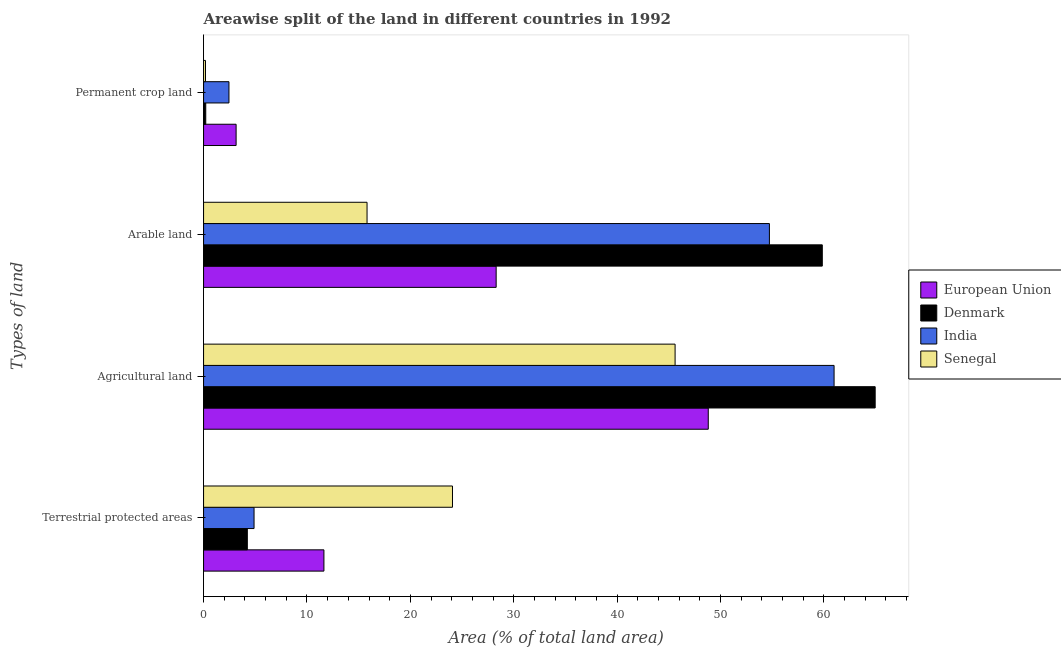What is the label of the 2nd group of bars from the top?
Make the answer very short. Arable land. What is the percentage of land under terrestrial protection in European Union?
Ensure brevity in your answer.  11.64. Across all countries, what is the maximum percentage of area under arable land?
Offer a very short reply. 59.84. Across all countries, what is the minimum percentage of area under permanent crop land?
Provide a succinct answer. 0.19. In which country was the percentage of land under terrestrial protection maximum?
Your response must be concise. Senegal. What is the total percentage of area under agricultural land in the graph?
Ensure brevity in your answer.  220.35. What is the difference between the percentage of area under agricultural land in Denmark and that in Senegal?
Your answer should be compact. 19.35. What is the difference between the percentage of area under permanent crop land in Senegal and the percentage of area under arable land in India?
Your answer should be very brief. -54.54. What is the average percentage of area under agricultural land per country?
Provide a succinct answer. 55.09. What is the difference between the percentage of area under permanent crop land and percentage of area under arable land in India?
Keep it short and to the point. -52.27. In how many countries, is the percentage of area under permanent crop land greater than 18 %?
Give a very brief answer. 0. What is the ratio of the percentage of area under arable land in Senegal to that in India?
Offer a terse response. 0.29. Is the percentage of land under terrestrial protection in Senegal less than that in Denmark?
Your response must be concise. No. What is the difference between the highest and the second highest percentage of land under terrestrial protection?
Ensure brevity in your answer.  12.43. What is the difference between the highest and the lowest percentage of area under permanent crop land?
Offer a terse response. 2.96. Is the sum of the percentage of area under agricultural land in Senegal and India greater than the maximum percentage of land under terrestrial protection across all countries?
Offer a very short reply. Yes. Is it the case that in every country, the sum of the percentage of land under terrestrial protection and percentage of area under permanent crop land is greater than the sum of percentage of area under arable land and percentage of area under agricultural land?
Ensure brevity in your answer.  Yes. What does the 3rd bar from the top in Agricultural land represents?
Your answer should be very brief. Denmark. What does the 1st bar from the bottom in Agricultural land represents?
Offer a terse response. European Union. How many bars are there?
Your answer should be very brief. 16. Are all the bars in the graph horizontal?
Your answer should be very brief. Yes. How many countries are there in the graph?
Your response must be concise. 4. Are the values on the major ticks of X-axis written in scientific E-notation?
Keep it short and to the point. No. Where does the legend appear in the graph?
Offer a terse response. Center right. How many legend labels are there?
Your answer should be very brief. 4. What is the title of the graph?
Your answer should be compact. Areawise split of the land in different countries in 1992. What is the label or title of the X-axis?
Make the answer very short. Area (% of total land area). What is the label or title of the Y-axis?
Ensure brevity in your answer.  Types of land. What is the Area (% of total land area) in European Union in Terrestrial protected areas?
Offer a terse response. 11.64. What is the Area (% of total land area) in Denmark in Terrestrial protected areas?
Your answer should be very brief. 4.23. What is the Area (% of total land area) in India in Terrestrial protected areas?
Offer a very short reply. 4.88. What is the Area (% of total land area) of Senegal in Terrestrial protected areas?
Your answer should be compact. 24.07. What is the Area (% of total land area) in European Union in Agricultural land?
Keep it short and to the point. 48.81. What is the Area (% of total land area) in Denmark in Agricultural land?
Keep it short and to the point. 64.95. What is the Area (% of total land area) in India in Agricultural land?
Provide a succinct answer. 60.98. What is the Area (% of total land area) of Senegal in Agricultural land?
Make the answer very short. 45.6. What is the Area (% of total land area) of European Union in Arable land?
Give a very brief answer. 28.3. What is the Area (% of total land area) of Denmark in Arable land?
Ensure brevity in your answer.  59.84. What is the Area (% of total land area) in India in Arable land?
Your response must be concise. 54.72. What is the Area (% of total land area) of Senegal in Arable land?
Your answer should be very brief. 15.81. What is the Area (% of total land area) of European Union in Permanent crop land?
Provide a short and direct response. 3.15. What is the Area (% of total land area) in Denmark in Permanent crop land?
Offer a terse response. 0.21. What is the Area (% of total land area) of India in Permanent crop land?
Keep it short and to the point. 2.46. What is the Area (% of total land area) in Senegal in Permanent crop land?
Provide a succinct answer. 0.19. Across all Types of land, what is the maximum Area (% of total land area) in European Union?
Keep it short and to the point. 48.81. Across all Types of land, what is the maximum Area (% of total land area) of Denmark?
Provide a succinct answer. 64.95. Across all Types of land, what is the maximum Area (% of total land area) of India?
Provide a succinct answer. 60.98. Across all Types of land, what is the maximum Area (% of total land area) of Senegal?
Your answer should be very brief. 45.6. Across all Types of land, what is the minimum Area (% of total land area) of European Union?
Your response must be concise. 3.15. Across all Types of land, what is the minimum Area (% of total land area) of Denmark?
Make the answer very short. 0.21. Across all Types of land, what is the minimum Area (% of total land area) of India?
Make the answer very short. 2.46. Across all Types of land, what is the minimum Area (% of total land area) in Senegal?
Your answer should be very brief. 0.19. What is the total Area (% of total land area) of European Union in the graph?
Offer a terse response. 91.9. What is the total Area (% of total land area) of Denmark in the graph?
Ensure brevity in your answer.  129.24. What is the total Area (% of total land area) in India in the graph?
Your answer should be compact. 123.04. What is the total Area (% of total land area) of Senegal in the graph?
Offer a very short reply. 85.67. What is the difference between the Area (% of total land area) in European Union in Terrestrial protected areas and that in Agricultural land?
Ensure brevity in your answer.  -37.17. What is the difference between the Area (% of total land area) in Denmark in Terrestrial protected areas and that in Agricultural land?
Your response must be concise. -60.72. What is the difference between the Area (% of total land area) in India in Terrestrial protected areas and that in Agricultural land?
Keep it short and to the point. -56.1. What is the difference between the Area (% of total land area) of Senegal in Terrestrial protected areas and that in Agricultural land?
Offer a very short reply. -21.53. What is the difference between the Area (% of total land area) of European Union in Terrestrial protected areas and that in Arable land?
Provide a succinct answer. -16.66. What is the difference between the Area (% of total land area) of Denmark in Terrestrial protected areas and that in Arable land?
Your answer should be compact. -55.61. What is the difference between the Area (% of total land area) in India in Terrestrial protected areas and that in Arable land?
Ensure brevity in your answer.  -49.84. What is the difference between the Area (% of total land area) in Senegal in Terrestrial protected areas and that in Arable land?
Give a very brief answer. 8.26. What is the difference between the Area (% of total land area) of European Union in Terrestrial protected areas and that in Permanent crop land?
Give a very brief answer. 8.49. What is the difference between the Area (% of total land area) of Denmark in Terrestrial protected areas and that in Permanent crop land?
Ensure brevity in your answer.  4.02. What is the difference between the Area (% of total land area) of India in Terrestrial protected areas and that in Permanent crop land?
Offer a very short reply. 2.43. What is the difference between the Area (% of total land area) of Senegal in Terrestrial protected areas and that in Permanent crop land?
Provide a short and direct response. 23.89. What is the difference between the Area (% of total land area) of European Union in Agricultural land and that in Arable land?
Provide a succinct answer. 20.51. What is the difference between the Area (% of total land area) of Denmark in Agricultural land and that in Arable land?
Your answer should be compact. 5.11. What is the difference between the Area (% of total land area) of India in Agricultural land and that in Arable land?
Provide a short and direct response. 6.26. What is the difference between the Area (% of total land area) of Senegal in Agricultural land and that in Arable land?
Ensure brevity in your answer.  29.79. What is the difference between the Area (% of total land area) of European Union in Agricultural land and that in Permanent crop land?
Offer a terse response. 45.66. What is the difference between the Area (% of total land area) of Denmark in Agricultural land and that in Permanent crop land?
Ensure brevity in your answer.  64.74. What is the difference between the Area (% of total land area) of India in Agricultural land and that in Permanent crop land?
Offer a very short reply. 58.52. What is the difference between the Area (% of total land area) in Senegal in Agricultural land and that in Permanent crop land?
Your answer should be compact. 45.42. What is the difference between the Area (% of total land area) of European Union in Arable land and that in Permanent crop land?
Keep it short and to the point. 25.15. What is the difference between the Area (% of total land area) in Denmark in Arable land and that in Permanent crop land?
Your answer should be compact. 59.63. What is the difference between the Area (% of total land area) in India in Arable land and that in Permanent crop land?
Ensure brevity in your answer.  52.27. What is the difference between the Area (% of total land area) in Senegal in Arable land and that in Permanent crop land?
Offer a terse response. 15.62. What is the difference between the Area (% of total land area) of European Union in Terrestrial protected areas and the Area (% of total land area) of Denmark in Agricultural land?
Your answer should be very brief. -53.31. What is the difference between the Area (% of total land area) of European Union in Terrestrial protected areas and the Area (% of total land area) of India in Agricultural land?
Your answer should be compact. -49.34. What is the difference between the Area (% of total land area) of European Union in Terrestrial protected areas and the Area (% of total land area) of Senegal in Agricultural land?
Keep it short and to the point. -33.96. What is the difference between the Area (% of total land area) in Denmark in Terrestrial protected areas and the Area (% of total land area) in India in Agricultural land?
Offer a terse response. -56.75. What is the difference between the Area (% of total land area) of Denmark in Terrestrial protected areas and the Area (% of total land area) of Senegal in Agricultural land?
Keep it short and to the point. -41.37. What is the difference between the Area (% of total land area) in India in Terrestrial protected areas and the Area (% of total land area) in Senegal in Agricultural land?
Provide a short and direct response. -40.72. What is the difference between the Area (% of total land area) of European Union in Terrestrial protected areas and the Area (% of total land area) of Denmark in Arable land?
Make the answer very short. -48.2. What is the difference between the Area (% of total land area) of European Union in Terrestrial protected areas and the Area (% of total land area) of India in Arable land?
Provide a succinct answer. -43.08. What is the difference between the Area (% of total land area) of European Union in Terrestrial protected areas and the Area (% of total land area) of Senegal in Arable land?
Keep it short and to the point. -4.17. What is the difference between the Area (% of total land area) of Denmark in Terrestrial protected areas and the Area (% of total land area) of India in Arable land?
Make the answer very short. -50.49. What is the difference between the Area (% of total land area) in Denmark in Terrestrial protected areas and the Area (% of total land area) in Senegal in Arable land?
Your answer should be compact. -11.58. What is the difference between the Area (% of total land area) in India in Terrestrial protected areas and the Area (% of total land area) in Senegal in Arable land?
Your answer should be very brief. -10.93. What is the difference between the Area (% of total land area) of European Union in Terrestrial protected areas and the Area (% of total land area) of Denmark in Permanent crop land?
Your answer should be very brief. 11.43. What is the difference between the Area (% of total land area) in European Union in Terrestrial protected areas and the Area (% of total land area) in India in Permanent crop land?
Offer a terse response. 9.18. What is the difference between the Area (% of total land area) in European Union in Terrestrial protected areas and the Area (% of total land area) in Senegal in Permanent crop land?
Your answer should be very brief. 11.45. What is the difference between the Area (% of total land area) of Denmark in Terrestrial protected areas and the Area (% of total land area) of India in Permanent crop land?
Offer a terse response. 1.78. What is the difference between the Area (% of total land area) in Denmark in Terrestrial protected areas and the Area (% of total land area) in Senegal in Permanent crop land?
Your answer should be compact. 4.05. What is the difference between the Area (% of total land area) of India in Terrestrial protected areas and the Area (% of total land area) of Senegal in Permanent crop land?
Your answer should be very brief. 4.7. What is the difference between the Area (% of total land area) in European Union in Agricultural land and the Area (% of total land area) in Denmark in Arable land?
Offer a terse response. -11.03. What is the difference between the Area (% of total land area) of European Union in Agricultural land and the Area (% of total land area) of India in Arable land?
Your response must be concise. -5.91. What is the difference between the Area (% of total land area) in European Union in Agricultural land and the Area (% of total land area) in Senegal in Arable land?
Give a very brief answer. 33. What is the difference between the Area (% of total land area) of Denmark in Agricultural land and the Area (% of total land area) of India in Arable land?
Offer a terse response. 10.23. What is the difference between the Area (% of total land area) of Denmark in Agricultural land and the Area (% of total land area) of Senegal in Arable land?
Make the answer very short. 49.14. What is the difference between the Area (% of total land area) of India in Agricultural land and the Area (% of total land area) of Senegal in Arable land?
Give a very brief answer. 45.17. What is the difference between the Area (% of total land area) of European Union in Agricultural land and the Area (% of total land area) of Denmark in Permanent crop land?
Provide a short and direct response. 48.6. What is the difference between the Area (% of total land area) in European Union in Agricultural land and the Area (% of total land area) in India in Permanent crop land?
Your answer should be compact. 46.36. What is the difference between the Area (% of total land area) of European Union in Agricultural land and the Area (% of total land area) of Senegal in Permanent crop land?
Provide a short and direct response. 48.62. What is the difference between the Area (% of total land area) in Denmark in Agricultural land and the Area (% of total land area) in India in Permanent crop land?
Keep it short and to the point. 62.5. What is the difference between the Area (% of total land area) of Denmark in Agricultural land and the Area (% of total land area) of Senegal in Permanent crop land?
Make the answer very short. 64.77. What is the difference between the Area (% of total land area) in India in Agricultural land and the Area (% of total land area) in Senegal in Permanent crop land?
Ensure brevity in your answer.  60.79. What is the difference between the Area (% of total land area) in European Union in Arable land and the Area (% of total land area) in Denmark in Permanent crop land?
Provide a short and direct response. 28.09. What is the difference between the Area (% of total land area) in European Union in Arable land and the Area (% of total land area) in India in Permanent crop land?
Provide a succinct answer. 25.84. What is the difference between the Area (% of total land area) in European Union in Arable land and the Area (% of total land area) in Senegal in Permanent crop land?
Provide a short and direct response. 28.11. What is the difference between the Area (% of total land area) of Denmark in Arable land and the Area (% of total land area) of India in Permanent crop land?
Your answer should be very brief. 57.38. What is the difference between the Area (% of total land area) of Denmark in Arable land and the Area (% of total land area) of Senegal in Permanent crop land?
Your answer should be very brief. 59.65. What is the difference between the Area (% of total land area) of India in Arable land and the Area (% of total land area) of Senegal in Permanent crop land?
Make the answer very short. 54.54. What is the average Area (% of total land area) of European Union per Types of land?
Your answer should be very brief. 22.97. What is the average Area (% of total land area) in Denmark per Types of land?
Provide a short and direct response. 32.31. What is the average Area (% of total land area) in India per Types of land?
Provide a succinct answer. 30.76. What is the average Area (% of total land area) of Senegal per Types of land?
Provide a succinct answer. 21.42. What is the difference between the Area (% of total land area) in European Union and Area (% of total land area) in Denmark in Terrestrial protected areas?
Your response must be concise. 7.41. What is the difference between the Area (% of total land area) in European Union and Area (% of total land area) in India in Terrestrial protected areas?
Your answer should be very brief. 6.76. What is the difference between the Area (% of total land area) of European Union and Area (% of total land area) of Senegal in Terrestrial protected areas?
Offer a terse response. -12.43. What is the difference between the Area (% of total land area) of Denmark and Area (% of total land area) of India in Terrestrial protected areas?
Provide a short and direct response. -0.65. What is the difference between the Area (% of total land area) in Denmark and Area (% of total land area) in Senegal in Terrestrial protected areas?
Your answer should be very brief. -19.84. What is the difference between the Area (% of total land area) in India and Area (% of total land area) in Senegal in Terrestrial protected areas?
Ensure brevity in your answer.  -19.19. What is the difference between the Area (% of total land area) in European Union and Area (% of total land area) in Denmark in Agricultural land?
Offer a terse response. -16.14. What is the difference between the Area (% of total land area) of European Union and Area (% of total land area) of India in Agricultural land?
Your response must be concise. -12.17. What is the difference between the Area (% of total land area) of European Union and Area (% of total land area) of Senegal in Agricultural land?
Make the answer very short. 3.21. What is the difference between the Area (% of total land area) of Denmark and Area (% of total land area) of India in Agricultural land?
Your answer should be compact. 3.97. What is the difference between the Area (% of total land area) of Denmark and Area (% of total land area) of Senegal in Agricultural land?
Your answer should be compact. 19.35. What is the difference between the Area (% of total land area) in India and Area (% of total land area) in Senegal in Agricultural land?
Make the answer very short. 15.38. What is the difference between the Area (% of total land area) in European Union and Area (% of total land area) in Denmark in Arable land?
Offer a very short reply. -31.54. What is the difference between the Area (% of total land area) of European Union and Area (% of total land area) of India in Arable land?
Your answer should be very brief. -26.43. What is the difference between the Area (% of total land area) of European Union and Area (% of total land area) of Senegal in Arable land?
Provide a short and direct response. 12.49. What is the difference between the Area (% of total land area) of Denmark and Area (% of total land area) of India in Arable land?
Provide a short and direct response. 5.12. What is the difference between the Area (% of total land area) of Denmark and Area (% of total land area) of Senegal in Arable land?
Make the answer very short. 44.03. What is the difference between the Area (% of total land area) in India and Area (% of total land area) in Senegal in Arable land?
Ensure brevity in your answer.  38.91. What is the difference between the Area (% of total land area) in European Union and Area (% of total land area) in Denmark in Permanent crop land?
Provide a succinct answer. 2.94. What is the difference between the Area (% of total land area) in European Union and Area (% of total land area) in India in Permanent crop land?
Offer a very short reply. 0.69. What is the difference between the Area (% of total land area) in European Union and Area (% of total land area) in Senegal in Permanent crop land?
Your answer should be compact. 2.96. What is the difference between the Area (% of total land area) in Denmark and Area (% of total land area) in India in Permanent crop land?
Provide a succinct answer. -2.24. What is the difference between the Area (% of total land area) of Denmark and Area (% of total land area) of Senegal in Permanent crop land?
Provide a short and direct response. 0.03. What is the difference between the Area (% of total land area) in India and Area (% of total land area) in Senegal in Permanent crop land?
Offer a terse response. 2.27. What is the ratio of the Area (% of total land area) of European Union in Terrestrial protected areas to that in Agricultural land?
Ensure brevity in your answer.  0.24. What is the ratio of the Area (% of total land area) of Denmark in Terrestrial protected areas to that in Agricultural land?
Your response must be concise. 0.07. What is the ratio of the Area (% of total land area) in India in Terrestrial protected areas to that in Agricultural land?
Your answer should be very brief. 0.08. What is the ratio of the Area (% of total land area) in Senegal in Terrestrial protected areas to that in Agricultural land?
Your answer should be very brief. 0.53. What is the ratio of the Area (% of total land area) in European Union in Terrestrial protected areas to that in Arable land?
Your response must be concise. 0.41. What is the ratio of the Area (% of total land area) in Denmark in Terrestrial protected areas to that in Arable land?
Your answer should be very brief. 0.07. What is the ratio of the Area (% of total land area) of India in Terrestrial protected areas to that in Arable land?
Your response must be concise. 0.09. What is the ratio of the Area (% of total land area) of Senegal in Terrestrial protected areas to that in Arable land?
Your response must be concise. 1.52. What is the ratio of the Area (% of total land area) of European Union in Terrestrial protected areas to that in Permanent crop land?
Ensure brevity in your answer.  3.7. What is the ratio of the Area (% of total land area) in Denmark in Terrestrial protected areas to that in Permanent crop land?
Ensure brevity in your answer.  19.96. What is the ratio of the Area (% of total land area) in India in Terrestrial protected areas to that in Permanent crop land?
Give a very brief answer. 1.99. What is the ratio of the Area (% of total land area) in Senegal in Terrestrial protected areas to that in Permanent crop land?
Your answer should be very brief. 128.75. What is the ratio of the Area (% of total land area) in European Union in Agricultural land to that in Arable land?
Ensure brevity in your answer.  1.73. What is the ratio of the Area (% of total land area) in Denmark in Agricultural land to that in Arable land?
Ensure brevity in your answer.  1.09. What is the ratio of the Area (% of total land area) in India in Agricultural land to that in Arable land?
Make the answer very short. 1.11. What is the ratio of the Area (% of total land area) in Senegal in Agricultural land to that in Arable land?
Provide a succinct answer. 2.88. What is the ratio of the Area (% of total land area) of European Union in Agricultural land to that in Permanent crop land?
Provide a short and direct response. 15.51. What is the ratio of the Area (% of total land area) of Denmark in Agricultural land to that in Permanent crop land?
Provide a short and direct response. 306.22. What is the ratio of the Area (% of total land area) of India in Agricultural land to that in Permanent crop land?
Your response must be concise. 24.84. What is the ratio of the Area (% of total land area) of Senegal in Agricultural land to that in Permanent crop land?
Offer a terse response. 243.89. What is the ratio of the Area (% of total land area) of European Union in Arable land to that in Permanent crop land?
Your answer should be compact. 8.99. What is the ratio of the Area (% of total land area) in Denmark in Arable land to that in Permanent crop land?
Ensure brevity in your answer.  282.11. What is the ratio of the Area (% of total land area) of India in Arable land to that in Permanent crop land?
Keep it short and to the point. 22.29. What is the ratio of the Area (% of total land area) in Senegal in Arable land to that in Permanent crop land?
Keep it short and to the point. 84.56. What is the difference between the highest and the second highest Area (% of total land area) of European Union?
Provide a short and direct response. 20.51. What is the difference between the highest and the second highest Area (% of total land area) in Denmark?
Your response must be concise. 5.11. What is the difference between the highest and the second highest Area (% of total land area) in India?
Your answer should be very brief. 6.26. What is the difference between the highest and the second highest Area (% of total land area) of Senegal?
Offer a terse response. 21.53. What is the difference between the highest and the lowest Area (% of total land area) in European Union?
Make the answer very short. 45.66. What is the difference between the highest and the lowest Area (% of total land area) in Denmark?
Your answer should be very brief. 64.74. What is the difference between the highest and the lowest Area (% of total land area) in India?
Your answer should be very brief. 58.52. What is the difference between the highest and the lowest Area (% of total land area) in Senegal?
Keep it short and to the point. 45.42. 